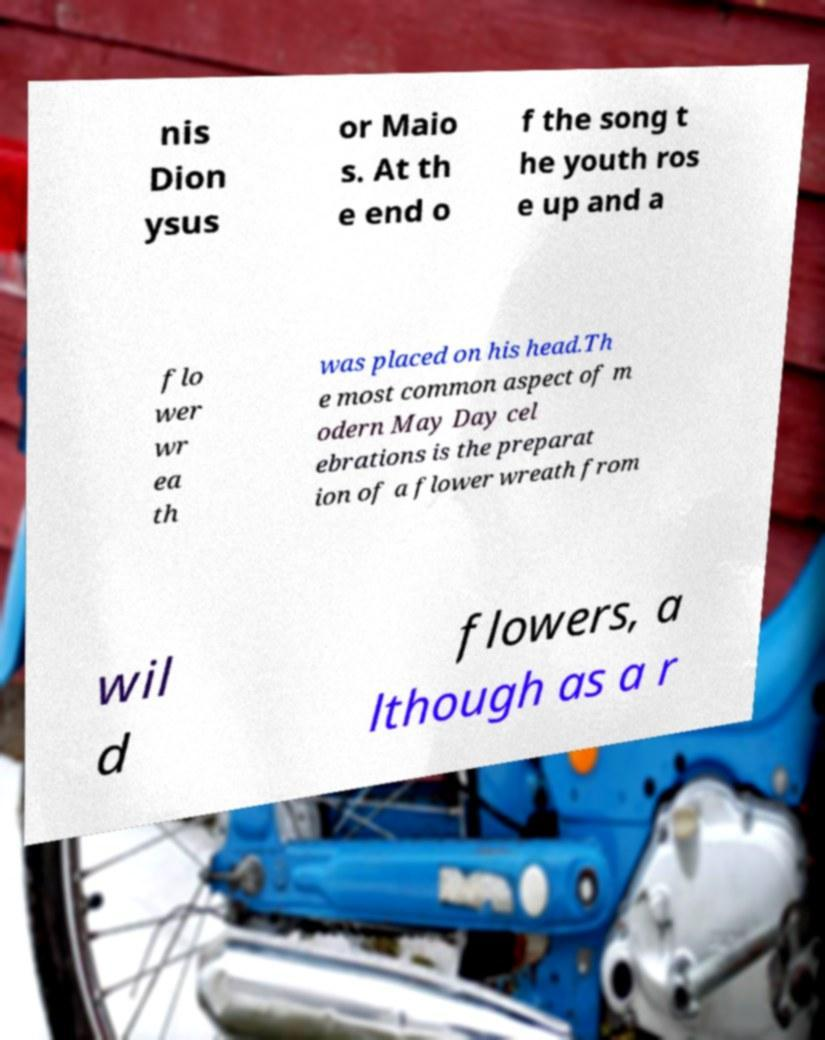Can you accurately transcribe the text from the provided image for me? nis Dion ysus or Maio s. At th e end o f the song t he youth ros e up and a flo wer wr ea th was placed on his head.Th e most common aspect of m odern May Day cel ebrations is the preparat ion of a flower wreath from wil d flowers, a lthough as a r 